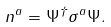Convert formula to latex. <formula><loc_0><loc_0><loc_500><loc_500>n ^ { a } = \Psi ^ { \dagger } \sigma ^ { a } \Psi .</formula> 